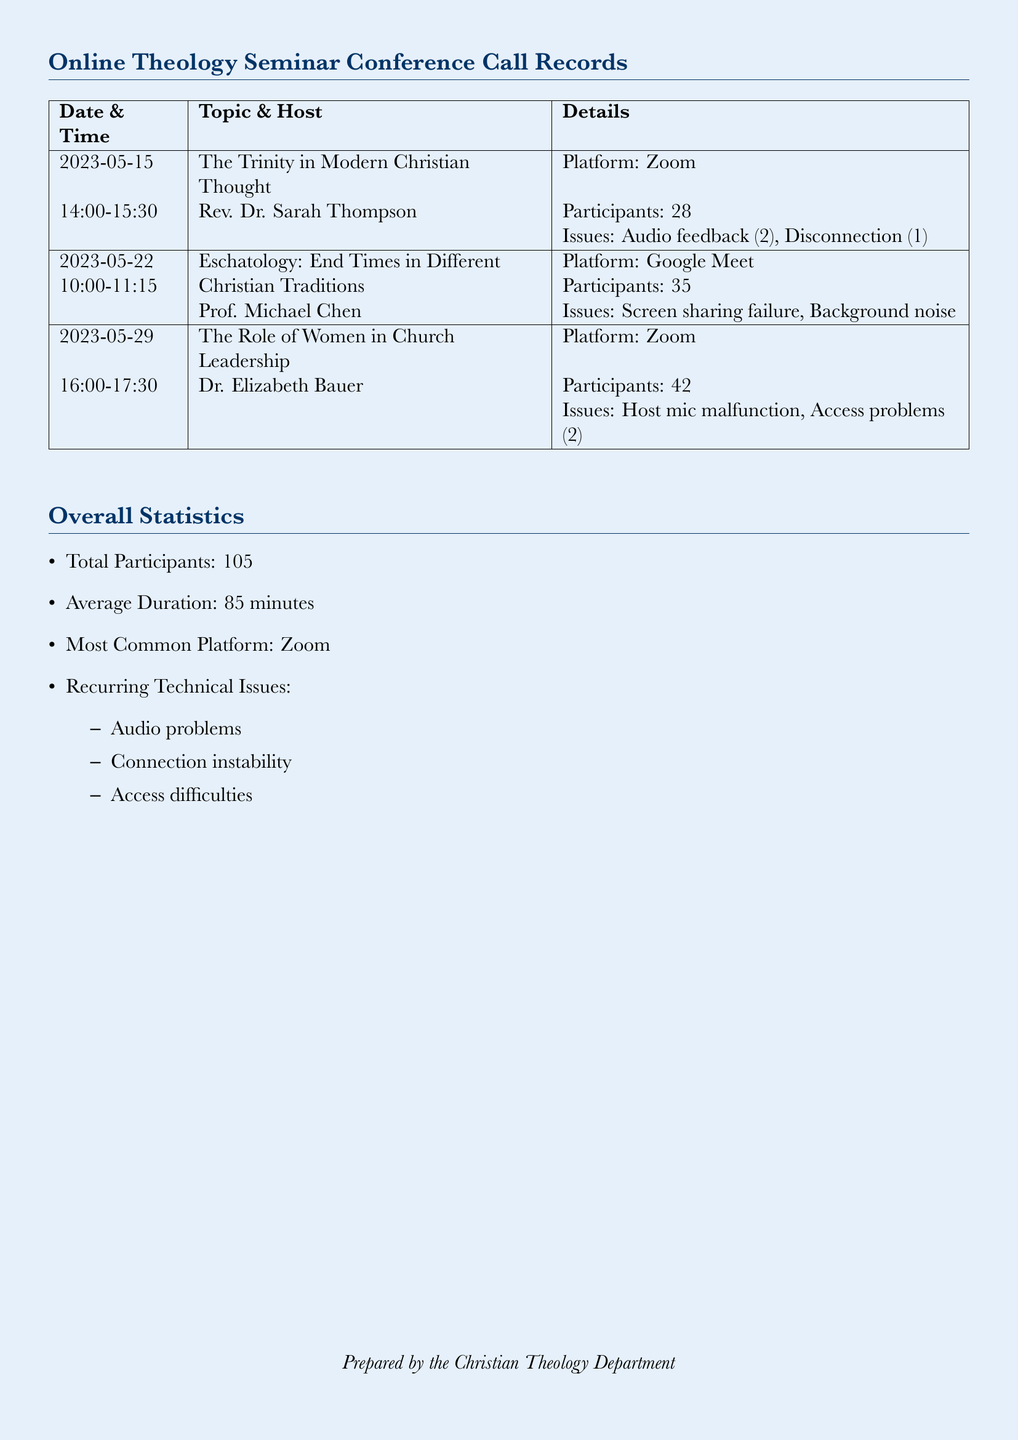What is the total number of participants? The total number of participants is calculated by adding the participants from each seminar: 28 + 35 + 42 = 105.
Answer: 105 What was the average duration of the seminars? The average duration is provided as part of the overall statistics section.
Answer: 85 minutes Who hosted the seminar on May 29th? The document lists Dr. Elizabeth Bauer as the host for the seminar on that date.
Answer: Dr. Elizabeth Bauer What technical issue occurred during the first seminar? The document mentions that audio feedback and one disconnection were issues during the seminar.
Answer: Audio feedback (2) Which platform was used for the Eschatology seminar? The platform used for the seminar is specifically noted in the document as Google Meet.
Answer: Google Meet What recurring technical issue is mentioned in the document? The document lists audio problems, connection instability, and access difficulties as recurring issues.
Answer: Audio problems How many seminars were conducted using Zoom? The document specifies two seminars were held on the Zoom platform, one on May 15 and one on May 29.
Answer: 2 What was the topic of the seminar hosted by Rev. Dr. Sarah Thompson? The document states the topic for that seminar was "The Trinity in Modern Christian Thought."
Answer: The Trinity in Modern Christian Thought What were the access problems reported during the seminar on the Role of Women in Church Leadership? The document details that there were access problems experienced by 2 participants during this seminar.
Answer: Access problems (2) 